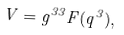<formula> <loc_0><loc_0><loc_500><loc_500>V = g ^ { 3 3 } F ( q ^ { 3 } ) ,</formula> 